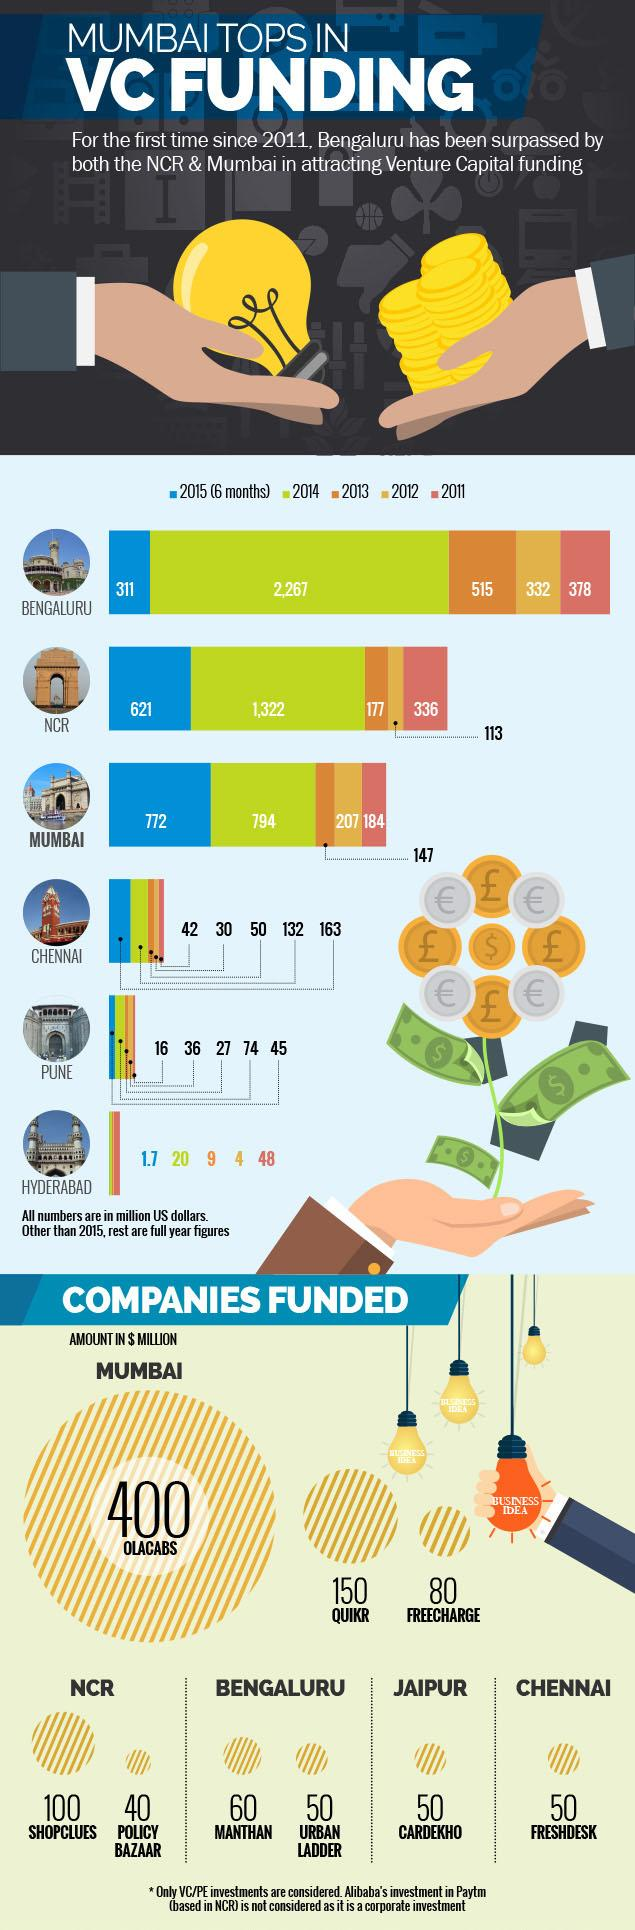Specify some key components in this picture. The year represented by the color green is 2014. In the year 2013, a total of 147 million US dollars was funded in Mumbai. In 2011, a total of 378 million US dollars was attracted as venture capital in Bengaluru. 